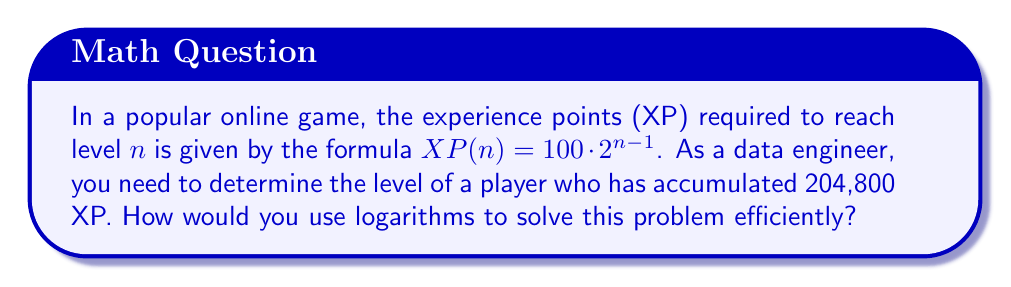Could you help me with this problem? To solve this problem using logarithms, we can follow these steps:

1) We start with the given formula: $XP(n) = 100 \cdot 2^{n-1}$

2) We know the player has 204,800 XP, so we can set up the equation:
   $204,800 = 100 \cdot 2^{n-1}$

3) First, let's divide both sides by 100:
   $2,048 = 2^{n-1}$

4) Now, we can apply the logarithm (base 2) to both sides:
   $\log_2(2,048) = \log_2(2^{n-1})$

5) Using the logarithm property $\log_a(a^x) = x$, we can simplify the right side:
   $\log_2(2,048) = n-1$

6) We know that $2^{11} = 2,048$, so $\log_2(2,048) = 11$

7) Substituting this value:
   $11 = n-1$

8) Solving for $n$:
   $n = 11 + 1 = 12$

Therefore, the player is at level 12.
Answer: 12 